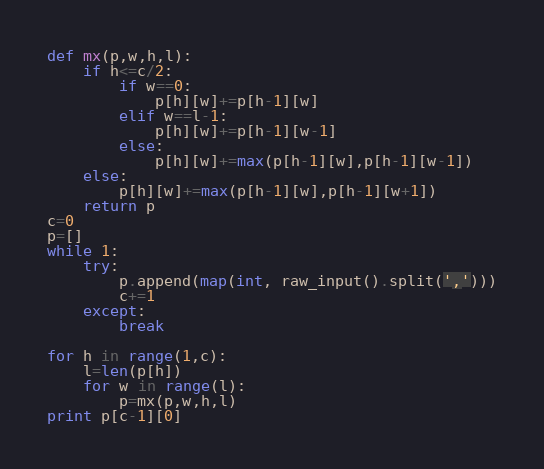<code> <loc_0><loc_0><loc_500><loc_500><_Python_>def mx(p,w,h,l):
    if h<=c/2:
        if w==0:
            p[h][w]+=p[h-1][w]
        elif w==l-1:
            p[h][w]+=p[h-1][w-1]
        else:
            p[h][w]+=max(p[h-1][w],p[h-1][w-1])
    else:
        p[h][w]+=max(p[h-1][w],p[h-1][w+1])
    return p
c=0
p=[]
while 1:
    try:
        p.append(map(int, raw_input().split(',')))
        c+=1
    except:
        break

for h in range(1,c):
    l=len(p[h])
    for w in range(l):
        p=mx(p,w,h,l)
print p[c-1][0]</code> 